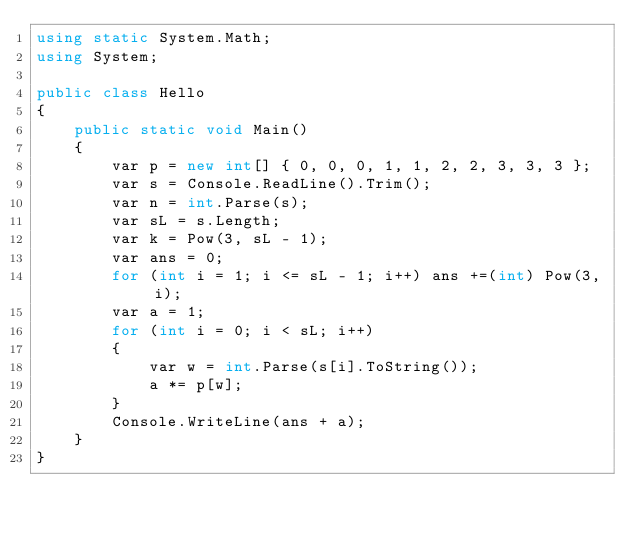Convert code to text. <code><loc_0><loc_0><loc_500><loc_500><_C#_>using static System.Math;
using System;

public class Hello
{
    public static void Main()
    {
        var p = new int[] { 0, 0, 0, 1, 1, 2, 2, 3, 3, 3 };
        var s = Console.ReadLine().Trim();
        var n = int.Parse(s);
        var sL = s.Length;
        var k = Pow(3, sL - 1);
        var ans = 0;
        for (int i = 1; i <= sL - 1; i++) ans +=(int) Pow(3, i);
        var a = 1;
        for (int i = 0; i < sL; i++)
        {
            var w = int.Parse(s[i].ToString());
            a *= p[w];
        }
        Console.WriteLine(ans + a);
    }
}
</code> 